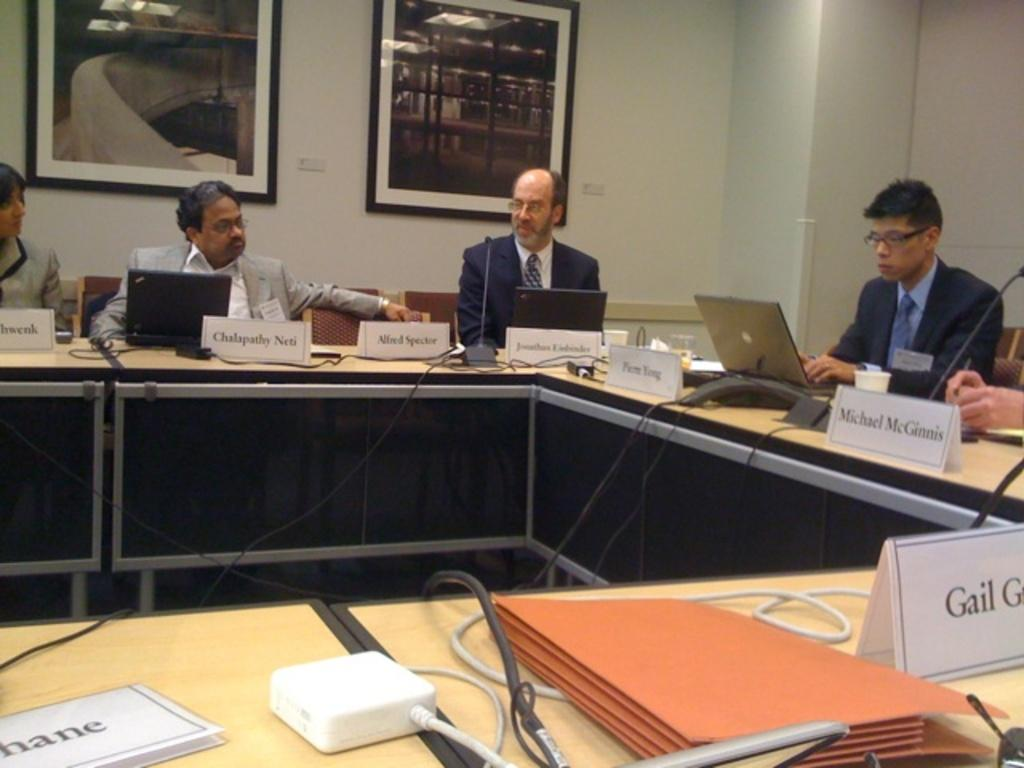<image>
Describe the image concisely. Several men sit around a table with name tags such as Chalapathy Neti in front of them. 